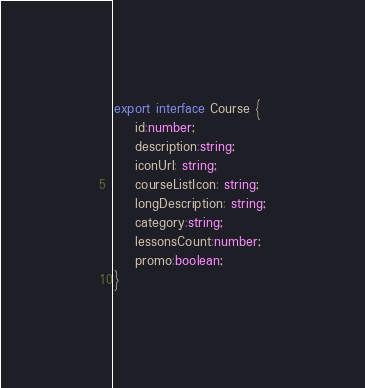<code> <loc_0><loc_0><loc_500><loc_500><_TypeScript_>

export interface Course {
    id:number;
    description:string;
    iconUrl: string;
    courseListIcon: string;
    longDescription: string;
    category:string;
    lessonsCount:number;
    promo:boolean;
}
</code> 